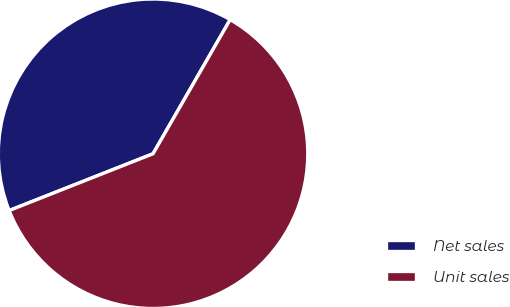Convert chart. <chart><loc_0><loc_0><loc_500><loc_500><pie_chart><fcel>Net sales<fcel>Unit sales<nl><fcel>39.29%<fcel>60.71%<nl></chart> 